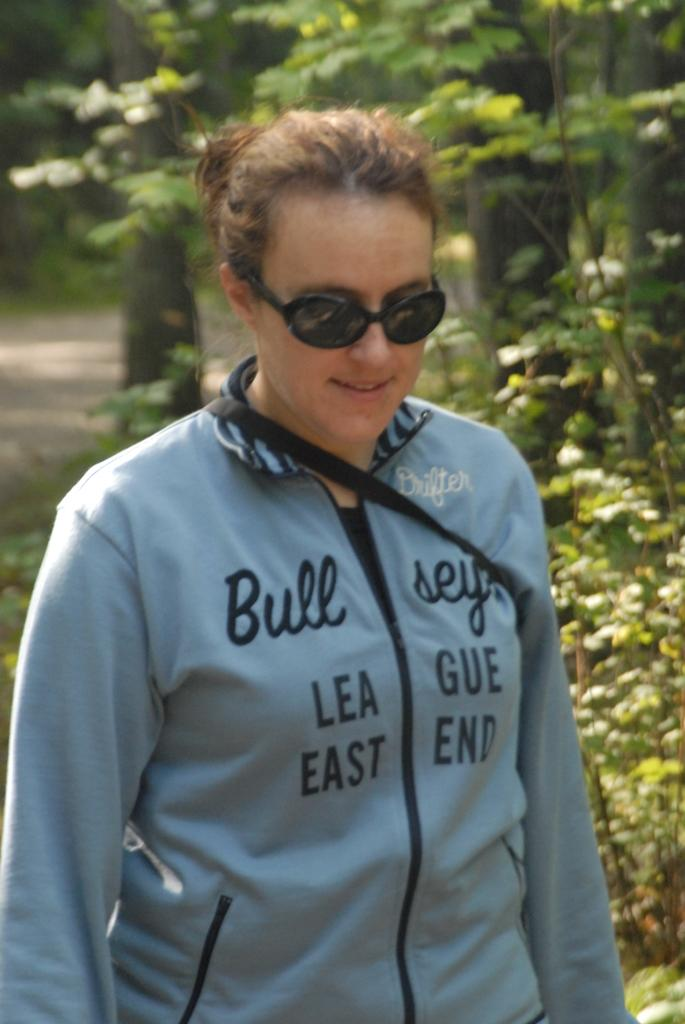Who is present in the image? There is a woman in the image. What is the woman wearing on her face? The woman is wearing goggles. What can be seen in the background of the image? There are trees visible in the background of the image. Where are the trees located in relation to the ground? The trees are on the ground. How does the woman blow the trees down in the image? The woman does not blow the trees down in the image; there is no indication of any such action. 